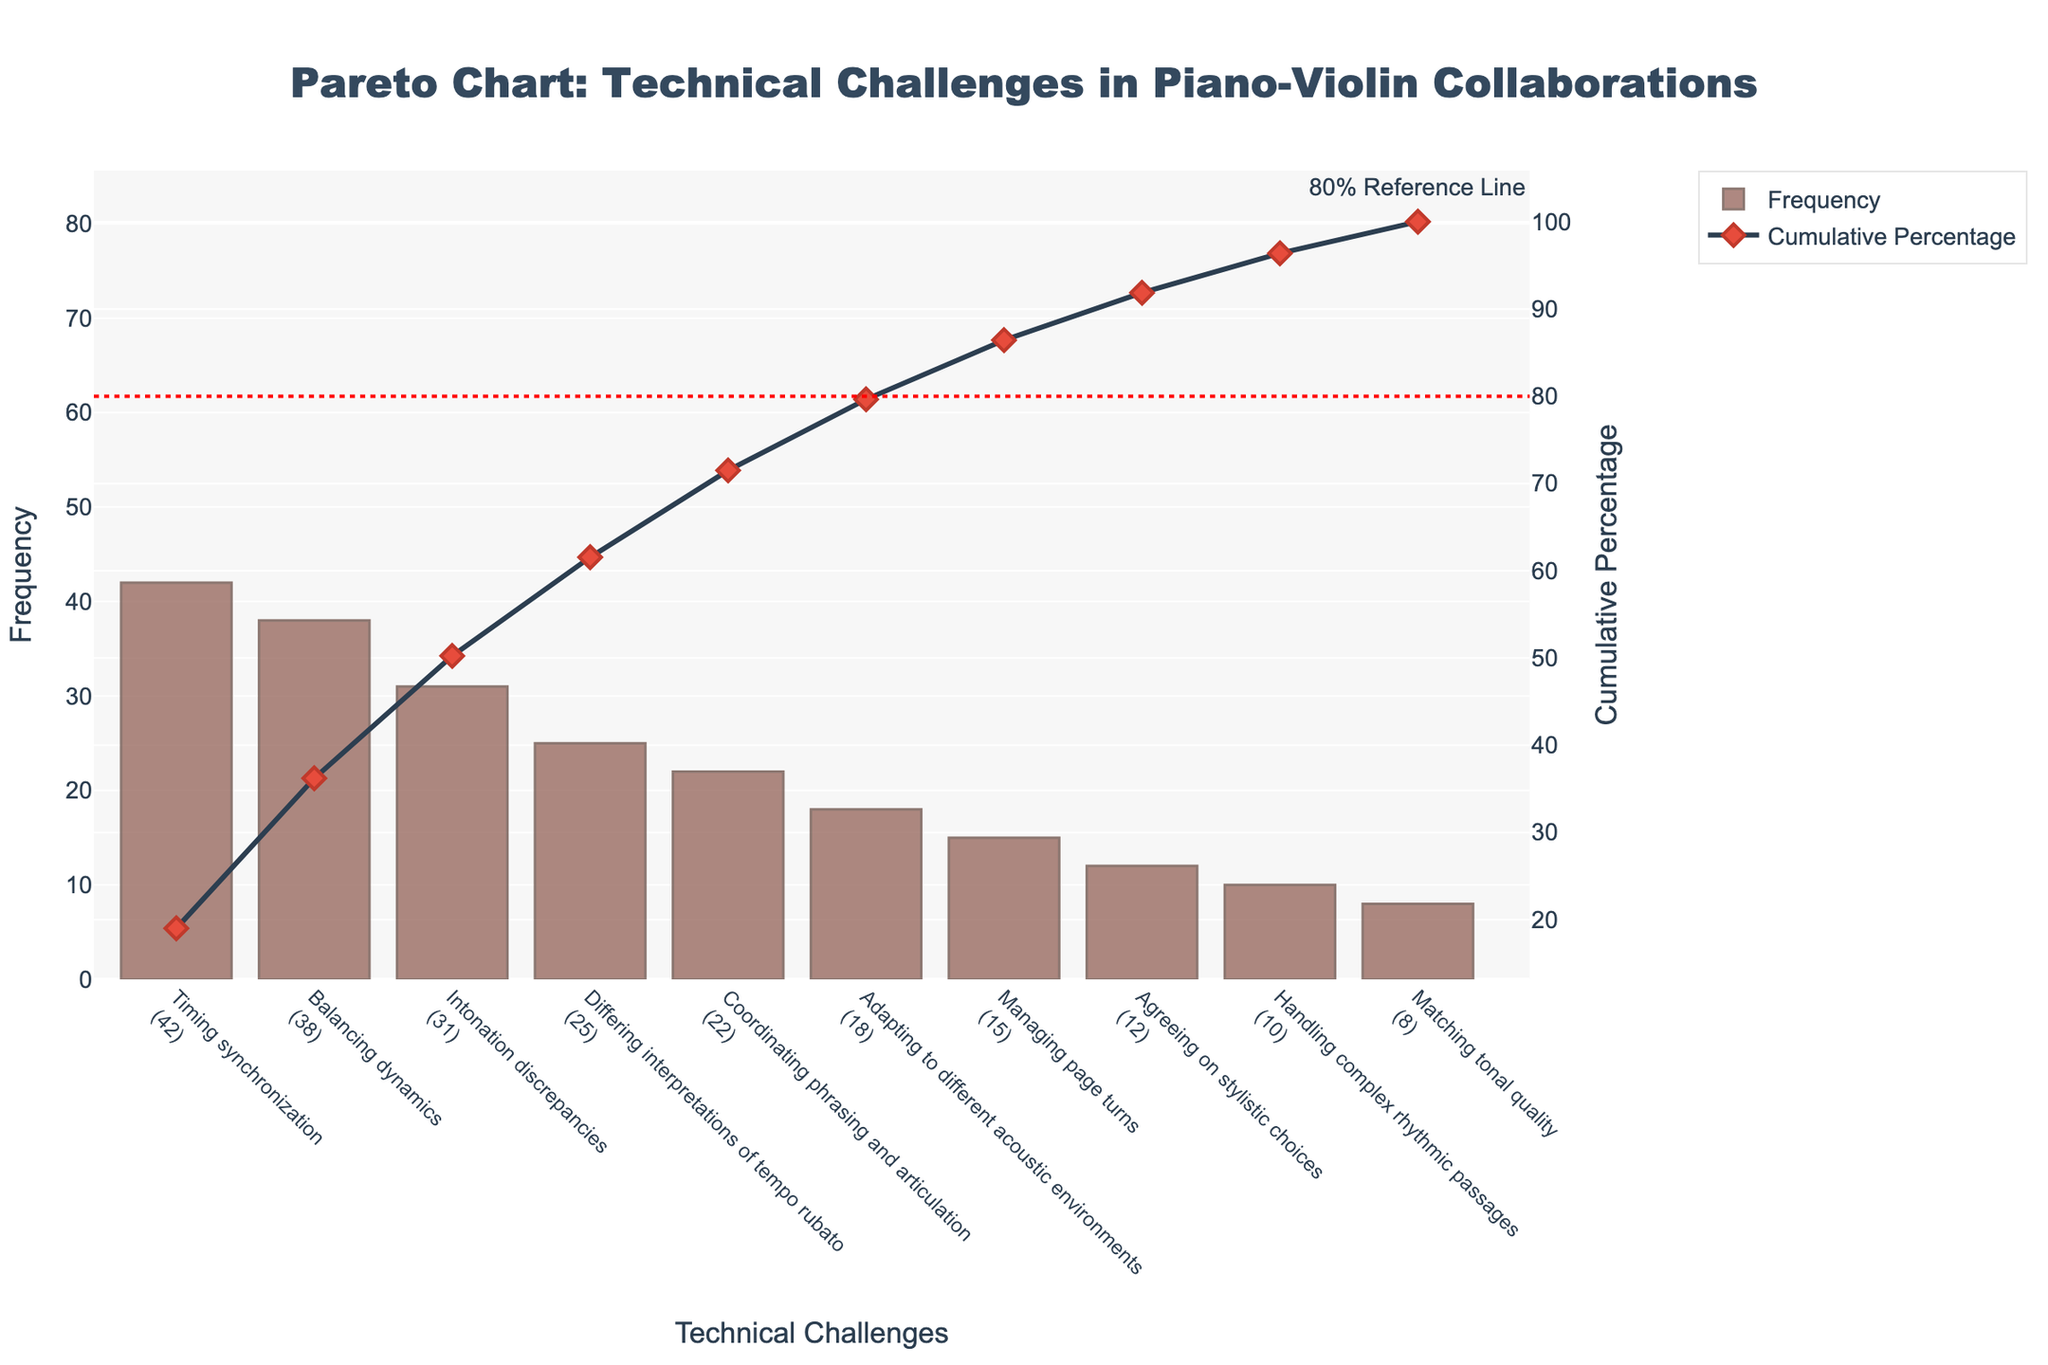What is the most common technical challenge faced in piano-violin collaborations? The bar with the highest frequency represents the most common technical challenge. From the chart, this is "Timing synchronization," which has the highest frequency.
Answer: Timing synchronization What is the cumulative percentage after addressing the top three issues? The cumulative percentages are plotted with a line. Adding the cumulative percentages for the top three issues: Timing synchronization (42), Balancing dynamics (38), and Intonation discrepancies (31), and then dividing the sum by the total frequency (42+38+31=111), the cumulative percentage approximates to 78.1%.
Answer: 78.1% Which technical challenge comes after "Differing interpretations of tempo rubato" in frequency? The bars are sorted in descending order of frequency. The next technical challenge after "Differing interpretations of tempo rubato" (25) is "Coordinating phrasing and articulation" (22).
Answer: Coordinating phrasing and articulation How many issues have a frequency of 20 or more? Count the bars with frequencies equal to or greater than 20. The issues meeting this criterion are Timing synchronization (42), Balancing dynamics (38), Intonation discrepancies (31), Differing interpretations of tempo rubato (25), and Coordinating phrasing and articulation (22). This makes a total of 5 issues.
Answer: 5 What is the combined frequency of the issues that account for more than 80% of the problems? Identify the issues up to but not including the point where the cumulative percentage exceeds 80%. The issues are Timing synchronization (42), Balancing dynamics (38), Intonation discrepancies (31), Differing interpretations of tempo rubato (25), Coordinating phrasing and articulation (22). The combined frequency is 42+38+31+25+22 = 158.
Answer: 158 What is the cumulative percentage of "Managing page turns"? Locate the cumulative percentage for "Managing page turns". According to the chart, it is at that point as well. The cumulative percentage for "Managing page turns" is represented directly on the secondary y-axis. It comes after "Adapting to different acoustic environments" and stands at 86.7%.
Answer: 86.7% How are the frequencies visually represented in the chart? The frequencies are visually represented by bars. Each bar's height corresponds to the frequency of the specific technical challenge.
Answer: Bars Which technical challenges together contribute to the first 70% of cumulative issues? Examine the cumulative percentage line and identify the issues that add up to approximately 70%. These include Timing synchronization (42), Balancing dynamics (38), Intonation discrepancies (31), and Differing interpretations of tempo rubato (25). These issues sum up to a cumulative percentage close to 70%.
Answer: Timing synchronization, Balancing dynamics, Intonation discrepancies, Differing interpretations of tempo rubato What stylistic element is used to mark the 80% reference line? The 80% reference line is marked using a dashed line, which is colored red.
Answer: Dashed red line What is the frequency of "Agreeing on stylistic choices"? Look at the bar corresponding to "Agreeing on stylistic choices". The number at the top indicates its frequency, which is 12.
Answer: 12 